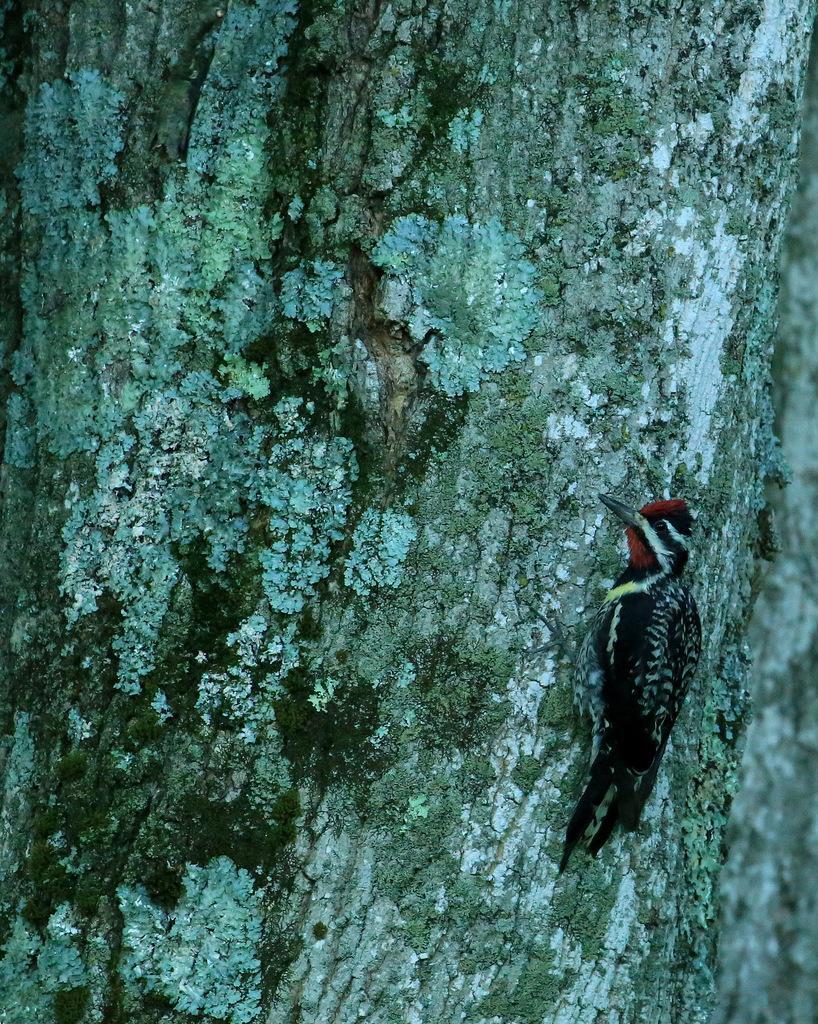Can you describe this image briefly? On the right side, there is a black color bird, standing on a branch of a tree. And the background is gray in color. 